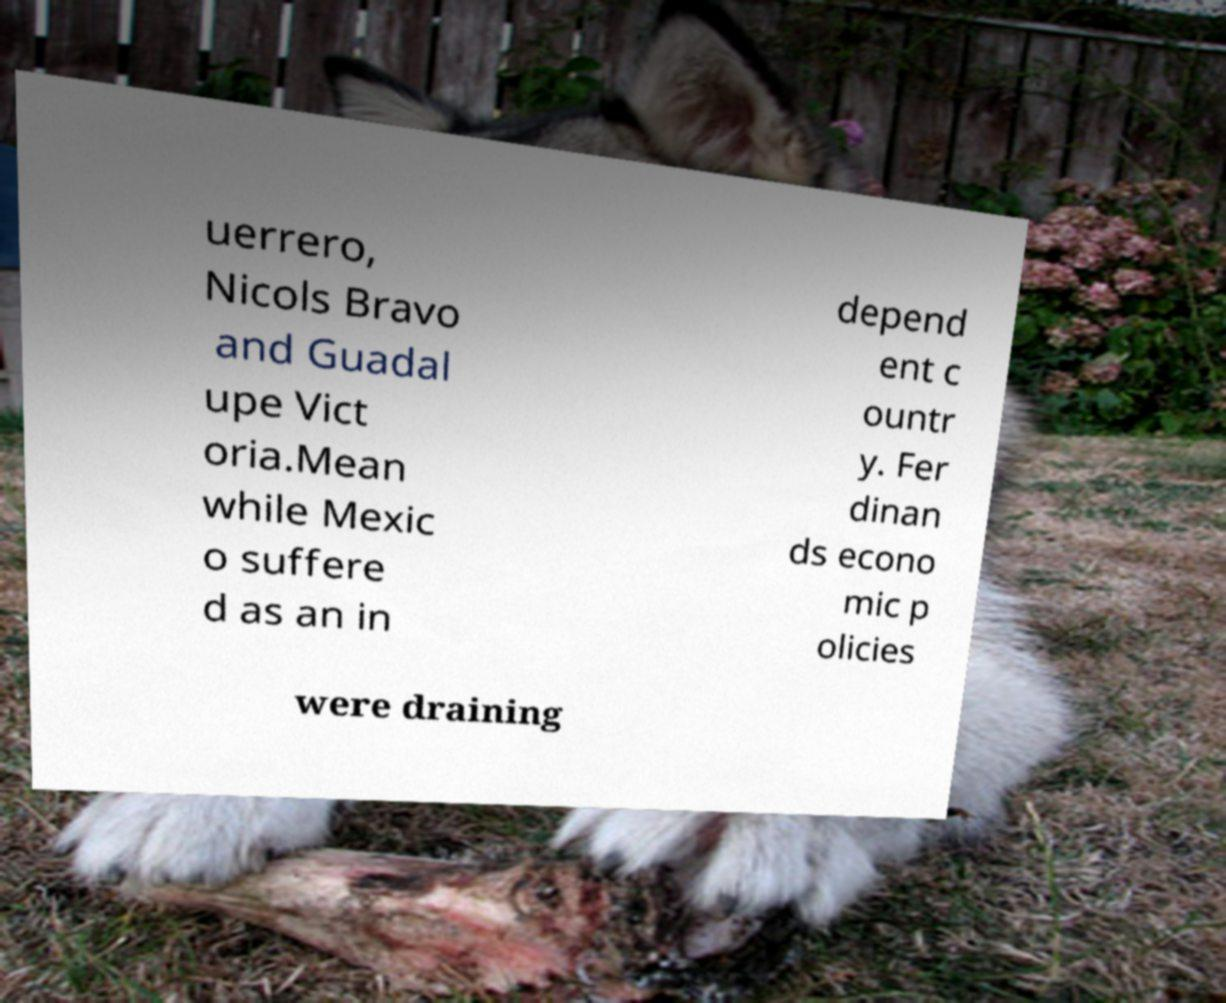I need the written content from this picture converted into text. Can you do that? uerrero, Nicols Bravo and Guadal upe Vict oria.Mean while Mexic o suffere d as an in depend ent c ountr y. Fer dinan ds econo mic p olicies were draining 